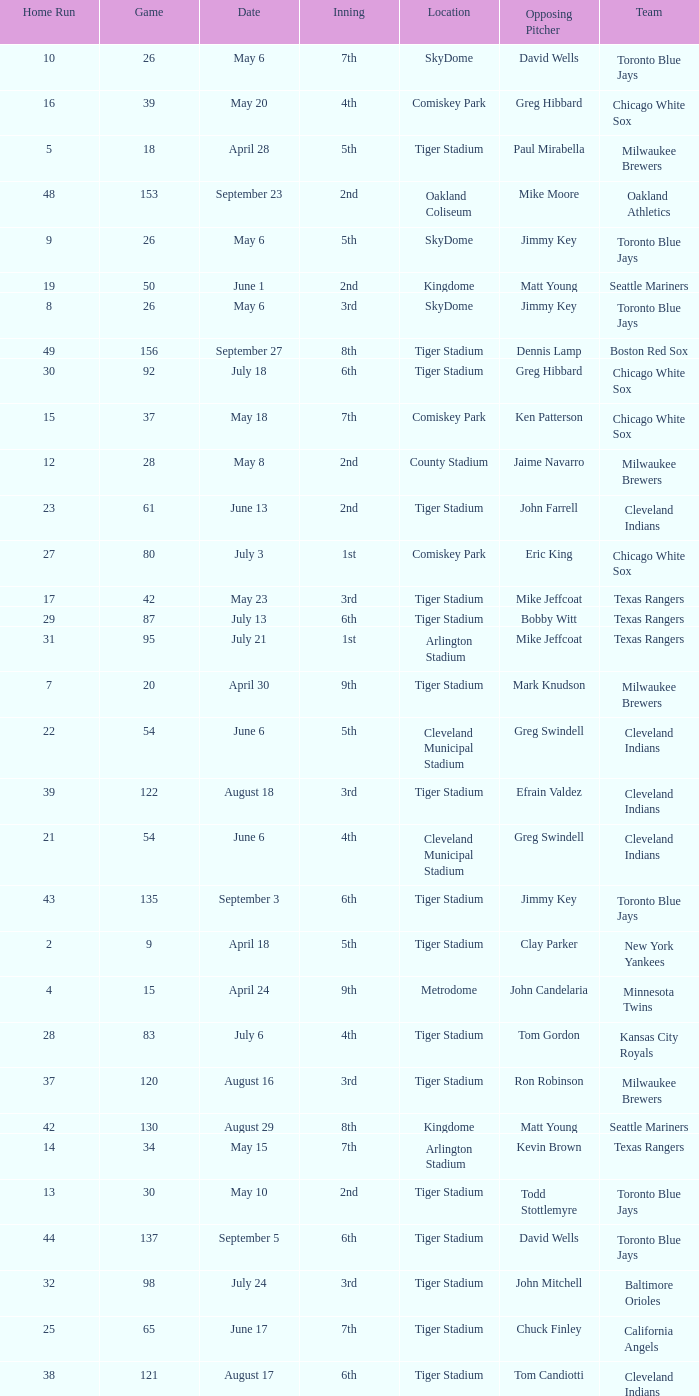What date was the game at Comiskey Park and had a 4th Inning? May 20. 